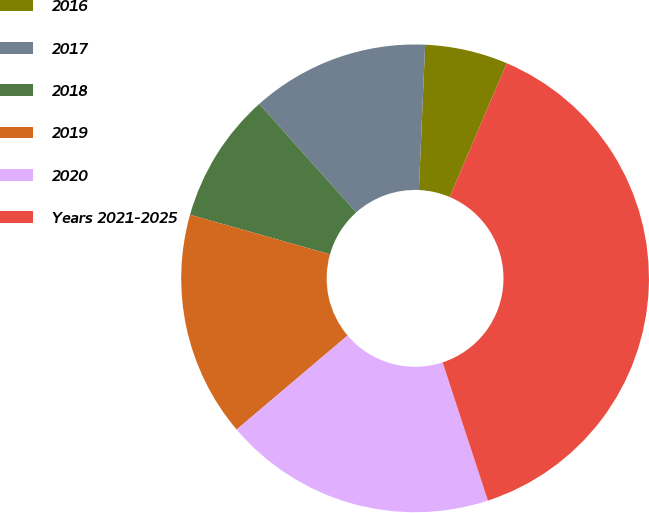Convert chart. <chart><loc_0><loc_0><loc_500><loc_500><pie_chart><fcel>2016<fcel>2017<fcel>2018<fcel>2019<fcel>2020<fcel>Years 2021-2025<nl><fcel>5.73%<fcel>12.29%<fcel>9.01%<fcel>15.57%<fcel>18.85%<fcel>38.54%<nl></chart> 